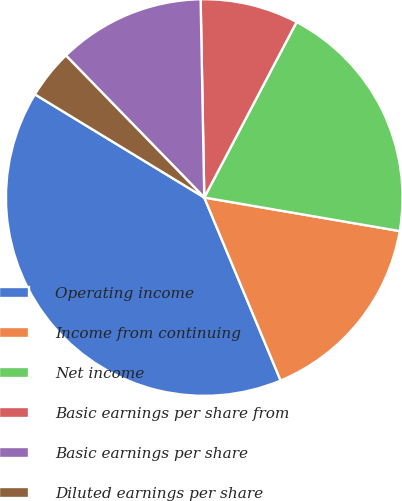<chart> <loc_0><loc_0><loc_500><loc_500><pie_chart><fcel>Operating income<fcel>Income from continuing<fcel>Net income<fcel>Basic earnings per share from<fcel>Basic earnings per share<fcel>Diluted earnings per share<nl><fcel>40.0%<fcel>16.0%<fcel>20.0%<fcel>8.0%<fcel>12.0%<fcel>4.0%<nl></chart> 